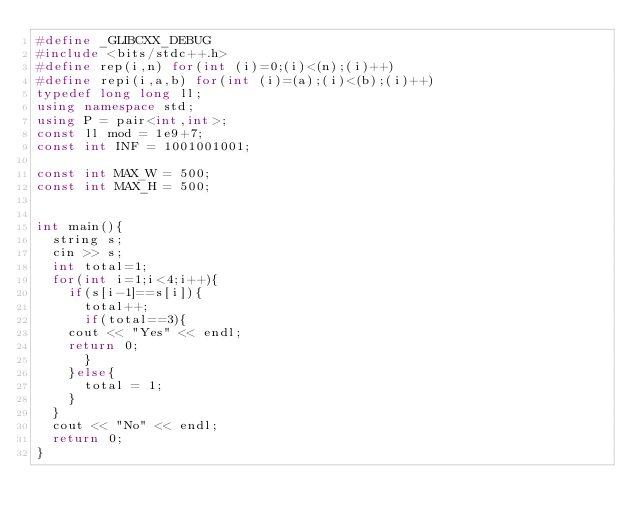<code> <loc_0><loc_0><loc_500><loc_500><_C++_>#define _GLIBCXX_DEBUG
#include <bits/stdc++.h>
#define rep(i,n) for(int (i)=0;(i)<(n);(i)++)
#define repi(i,a,b) for(int (i)=(a);(i)<(b);(i)++)
typedef long long ll;
using namespace std; 
using P = pair<int,int>;
const ll mod = 1e9+7;
const int INF = 1001001001;

const int MAX_W = 500;
const int MAX_H = 500;


int main(){
  string s;
  cin >> s;
  int total=1;
  for(int i=1;i<4;i++){
    if(s[i-1]==s[i]){
      total++;
      if(total==3){
	cout << "Yes" << endl;
	return 0;
      }
    }else{
      total = 1;
    }
  }
  cout << "No" << endl;
  return 0;
}
</code> 